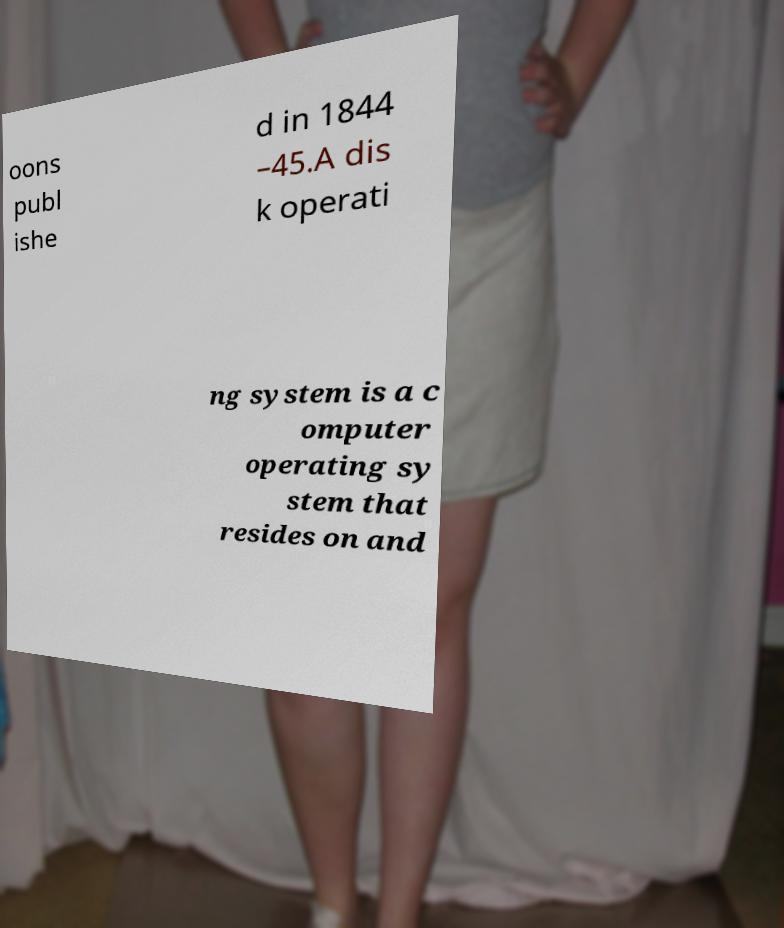There's text embedded in this image that I need extracted. Can you transcribe it verbatim? oons publ ishe d in 1844 –45.A dis k operati ng system is a c omputer operating sy stem that resides on and 